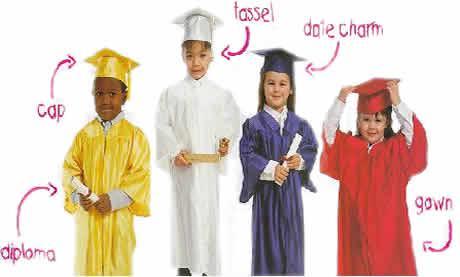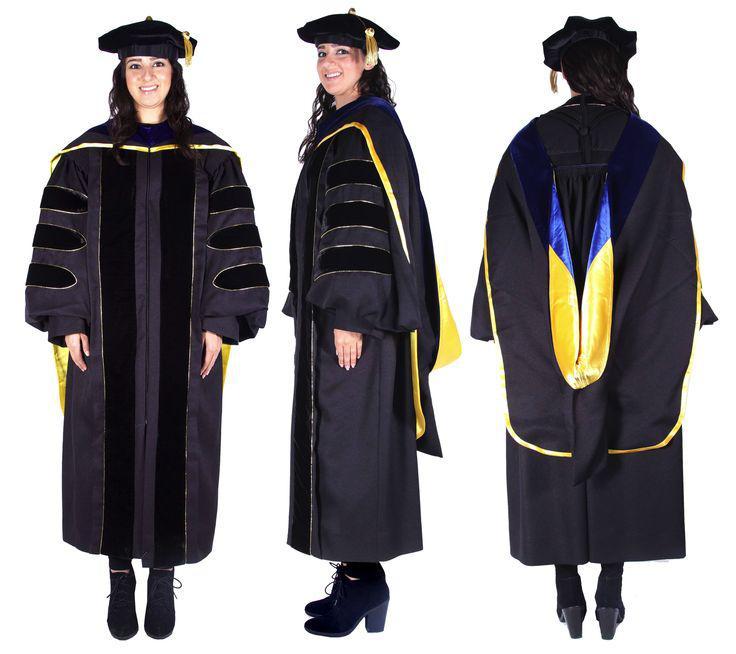The first image is the image on the left, the second image is the image on the right. Analyze the images presented: Is the assertion "The left image contains exactly four children modeling four different colored graduation robes with matching hats, and two of them hold rolled white diplomas." valid? Answer yes or no. Yes. The first image is the image on the left, the second image is the image on the right. For the images displayed, is the sentence "At least one person is wearing a white gown." factually correct? Answer yes or no. Yes. 